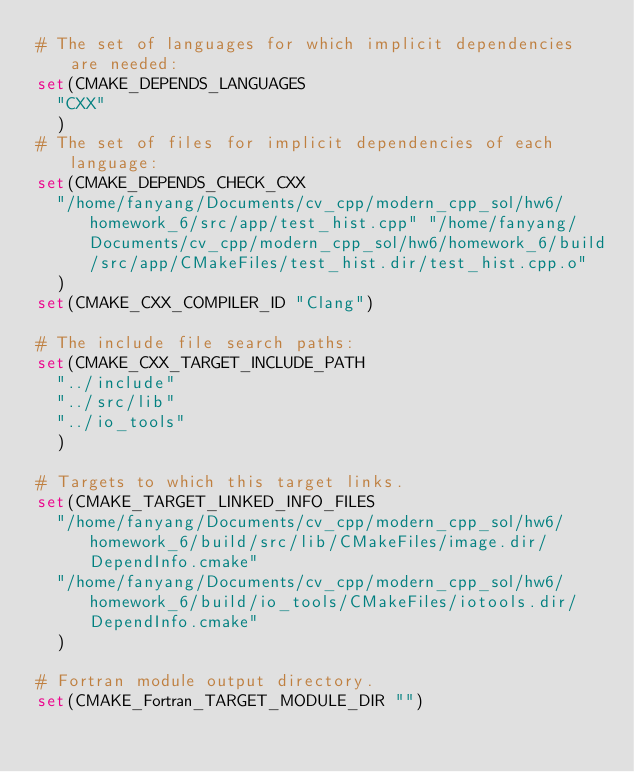<code> <loc_0><loc_0><loc_500><loc_500><_CMake_># The set of languages for which implicit dependencies are needed:
set(CMAKE_DEPENDS_LANGUAGES
  "CXX"
  )
# The set of files for implicit dependencies of each language:
set(CMAKE_DEPENDS_CHECK_CXX
  "/home/fanyang/Documents/cv_cpp/modern_cpp_sol/hw6/homework_6/src/app/test_hist.cpp" "/home/fanyang/Documents/cv_cpp/modern_cpp_sol/hw6/homework_6/build/src/app/CMakeFiles/test_hist.dir/test_hist.cpp.o"
  )
set(CMAKE_CXX_COMPILER_ID "Clang")

# The include file search paths:
set(CMAKE_CXX_TARGET_INCLUDE_PATH
  "../include"
  "../src/lib"
  "../io_tools"
  )

# Targets to which this target links.
set(CMAKE_TARGET_LINKED_INFO_FILES
  "/home/fanyang/Documents/cv_cpp/modern_cpp_sol/hw6/homework_6/build/src/lib/CMakeFiles/image.dir/DependInfo.cmake"
  "/home/fanyang/Documents/cv_cpp/modern_cpp_sol/hw6/homework_6/build/io_tools/CMakeFiles/iotools.dir/DependInfo.cmake"
  )

# Fortran module output directory.
set(CMAKE_Fortran_TARGET_MODULE_DIR "")
</code> 